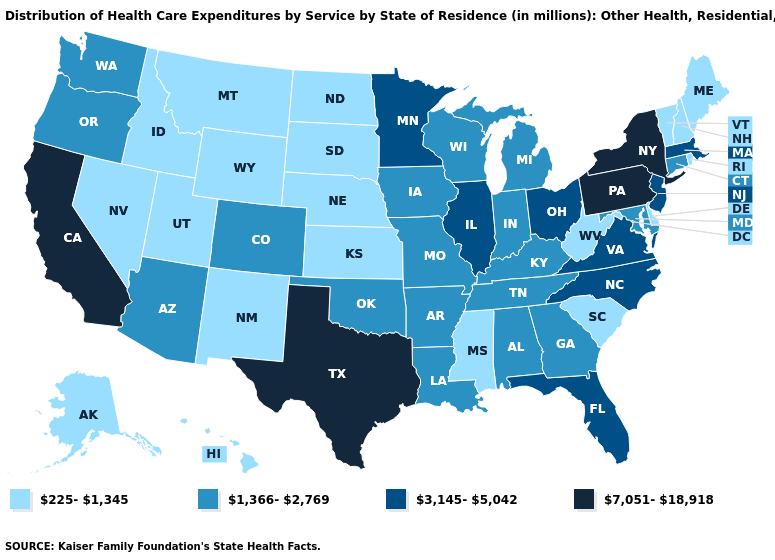What is the value of Indiana?
Give a very brief answer. 1,366-2,769. What is the value of Minnesota?
Be succinct. 3,145-5,042. Among the states that border Texas , does Oklahoma have the highest value?
Give a very brief answer. Yes. Does Colorado have a lower value than Rhode Island?
Answer briefly. No. What is the value of Idaho?
Write a very short answer. 225-1,345. Which states have the lowest value in the Northeast?
Answer briefly. Maine, New Hampshire, Rhode Island, Vermont. Does Hawaii have a lower value than Utah?
Give a very brief answer. No. What is the value of Delaware?
Be succinct. 225-1,345. Which states hav the highest value in the South?
Keep it brief. Texas. What is the value of Illinois?
Be succinct. 3,145-5,042. Among the states that border Nebraska , which have the lowest value?
Give a very brief answer. Kansas, South Dakota, Wyoming. What is the highest value in the USA?
Give a very brief answer. 7,051-18,918. Does the map have missing data?
Keep it brief. No. Among the states that border New Hampshire , which have the highest value?
Be succinct. Massachusetts. 